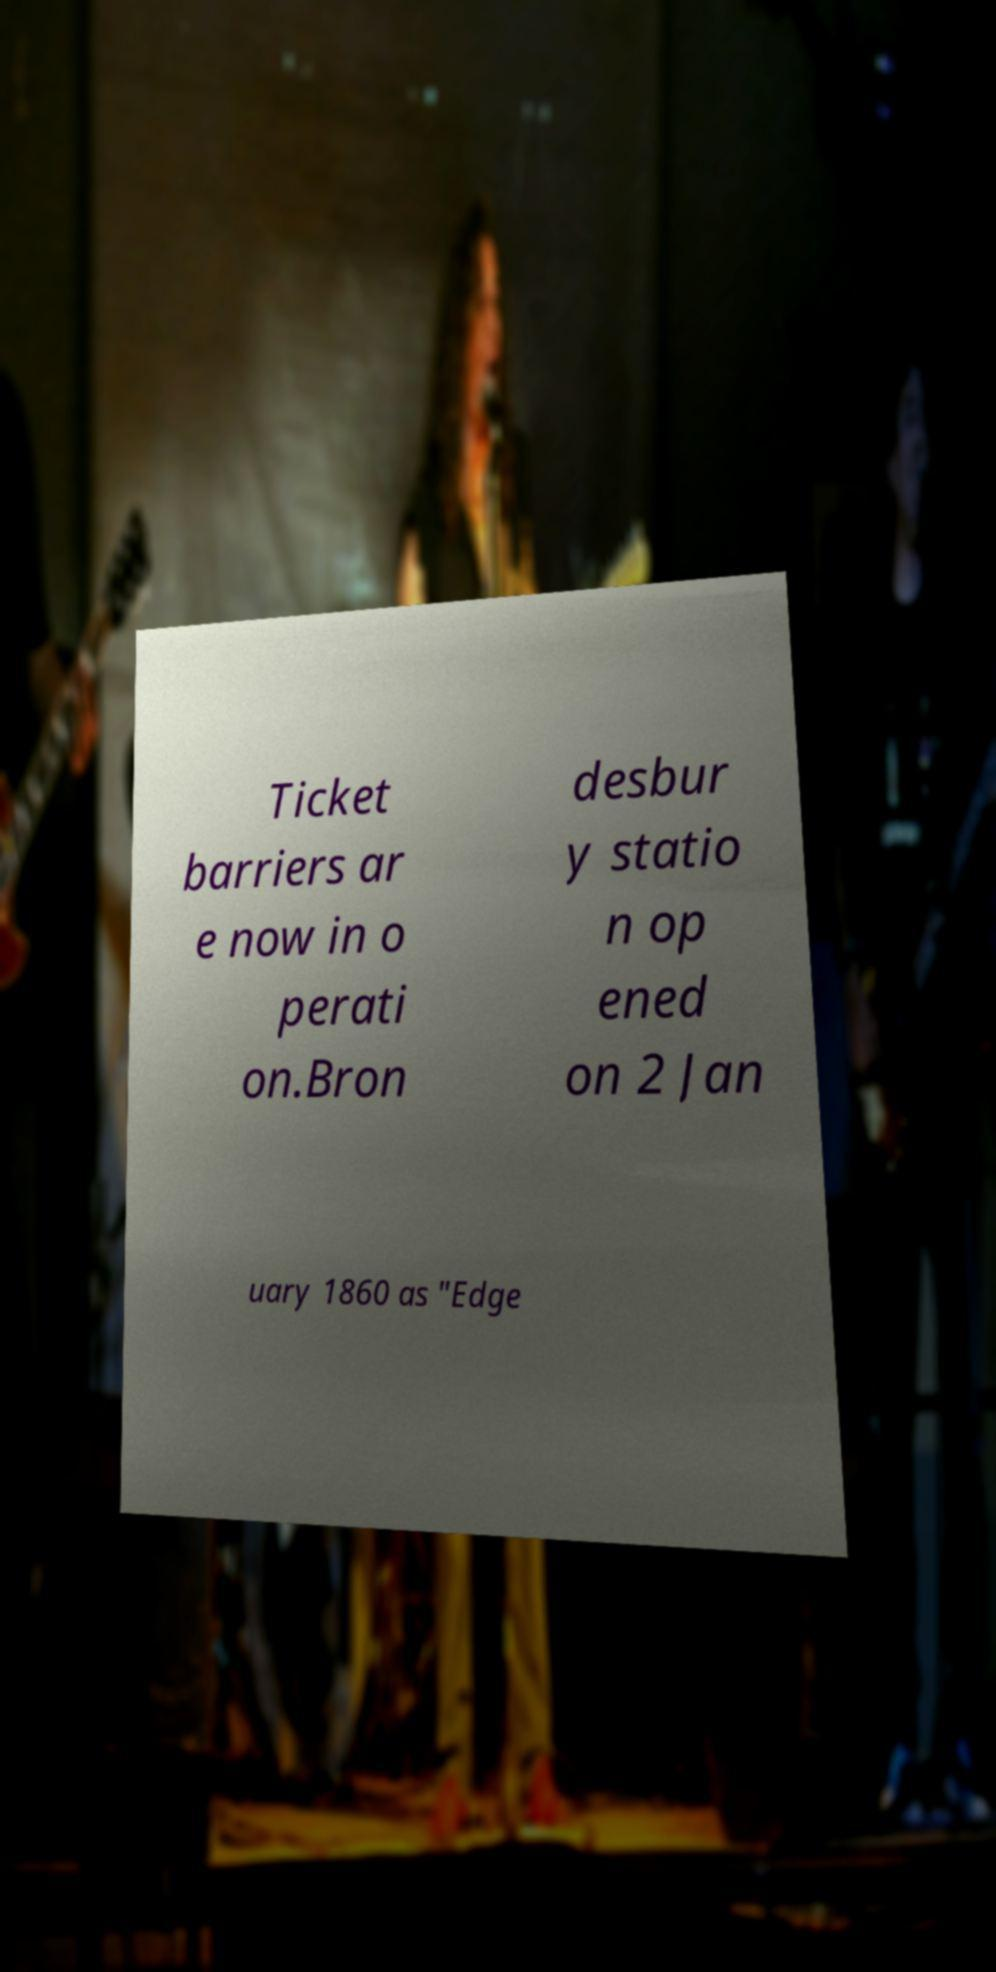For documentation purposes, I need the text within this image transcribed. Could you provide that? Ticket barriers ar e now in o perati on.Bron desbur y statio n op ened on 2 Jan uary 1860 as "Edge 